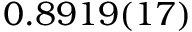<formula> <loc_0><loc_0><loc_500><loc_500>0 . 8 9 1 9 ( 1 7 )</formula> 